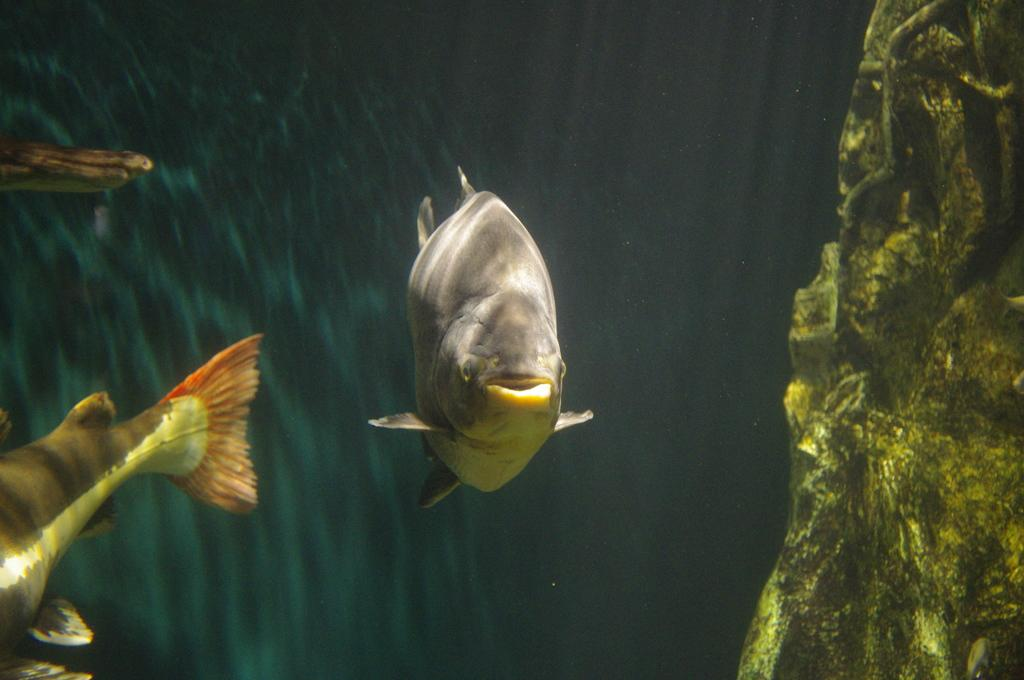What type of animals can be seen in the image? There are fishes in the water in the image. What object can be seen on the right side of the image? There is a rock on the right side of the image. What type of brass instrument can be seen in the image? There is no brass instrument present in the image; it features fishes in the water and a rock on the right side. Is there a trail visible in the image? There is no trail visible in the image; it only shows fishes in the water and a rock on the right side. 